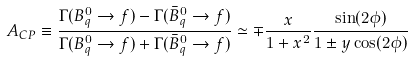Convert formula to latex. <formula><loc_0><loc_0><loc_500><loc_500>A _ { C P } \equiv \frac { \Gamma ( B ^ { 0 } _ { q } \rightarrow f ) - \Gamma ( \bar { B } ^ { 0 } _ { q } \rightarrow f ) } { \Gamma ( B ^ { 0 } _ { q } \rightarrow f ) + \Gamma ( \bar { B } ^ { 0 } _ { q } \rightarrow f ) } \simeq \mp \frac { x } { 1 + x ^ { 2 } } \frac { \sin ( 2 \phi ) } { 1 \pm y \cos ( 2 \phi ) }</formula> 